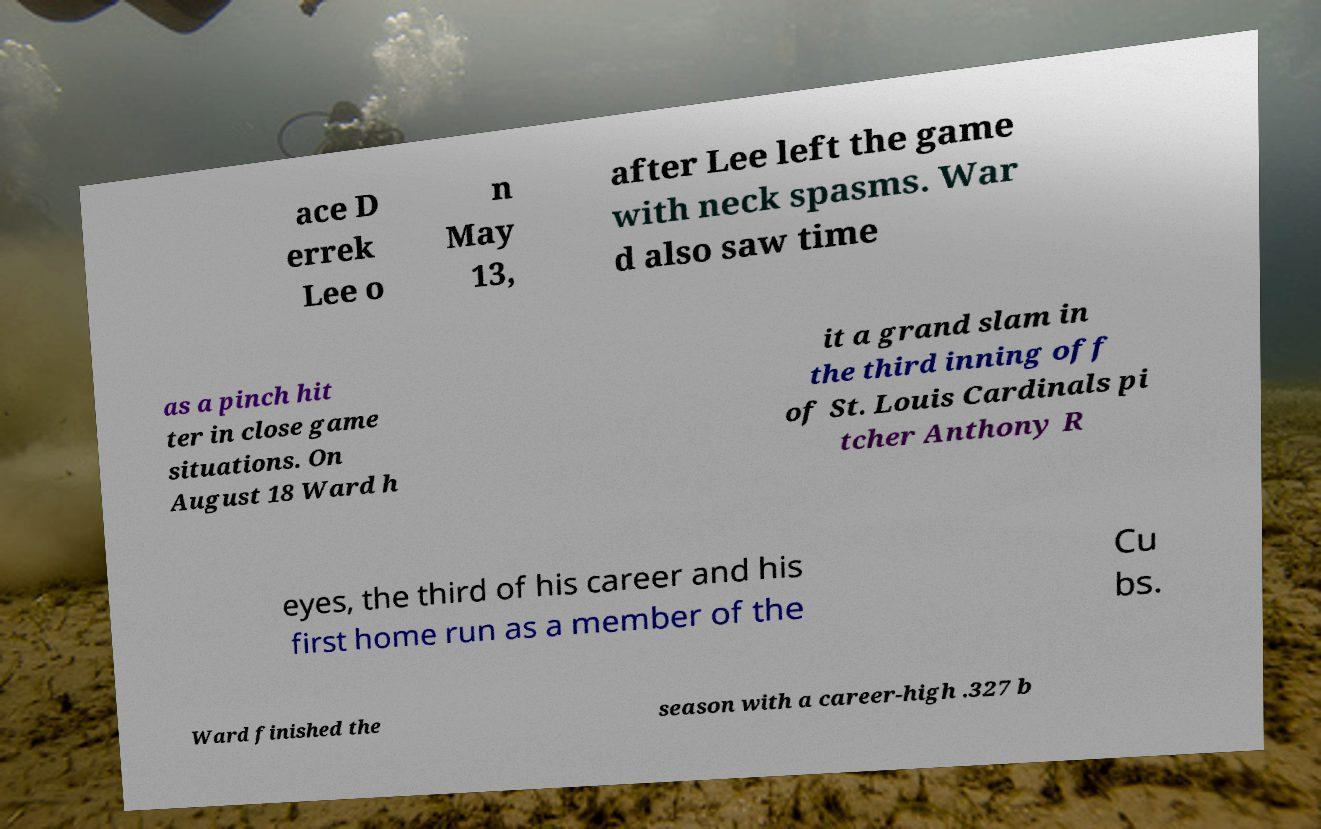For documentation purposes, I need the text within this image transcribed. Could you provide that? ace D errek Lee o n May 13, after Lee left the game with neck spasms. War d also saw time as a pinch hit ter in close game situations. On August 18 Ward h it a grand slam in the third inning off of St. Louis Cardinals pi tcher Anthony R eyes, the third of his career and his first home run as a member of the Cu bs. Ward finished the season with a career-high .327 b 